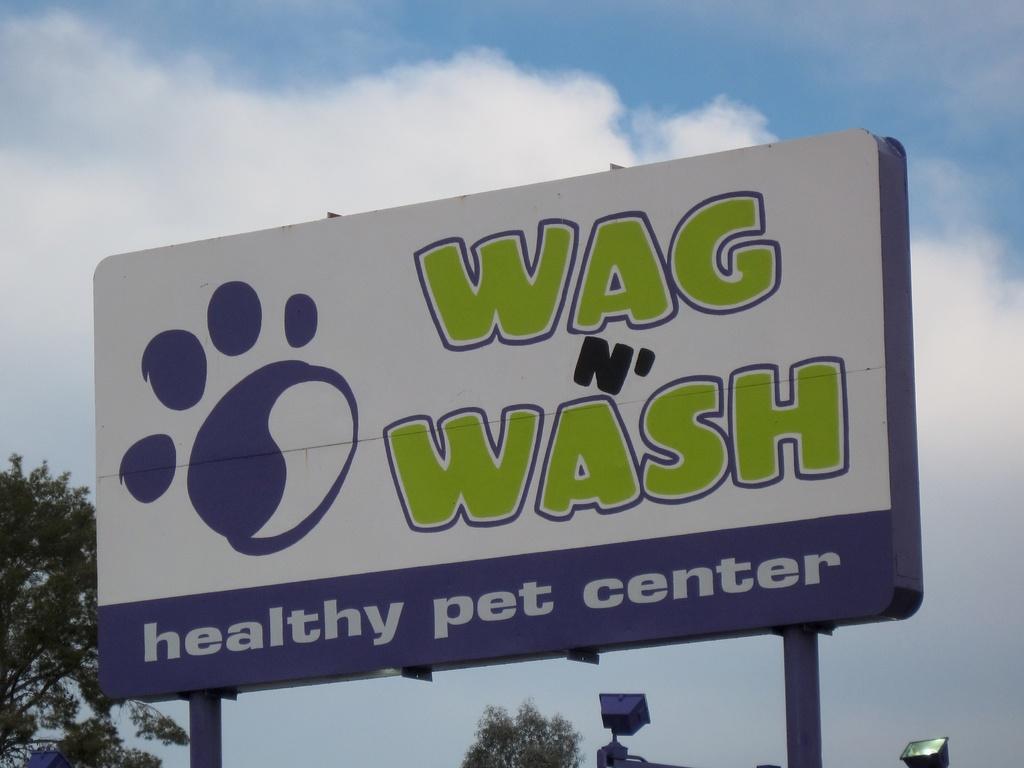What type of business is featured on the sign?
Give a very brief answer. Pet center. 